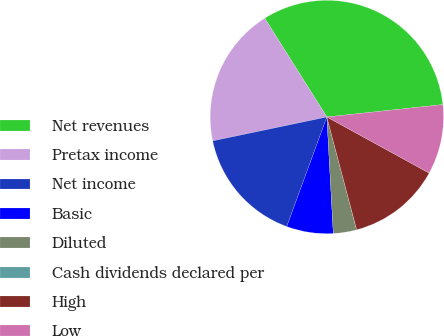<chart> <loc_0><loc_0><loc_500><loc_500><pie_chart><fcel>Net revenues<fcel>Pretax income<fcel>Net income<fcel>Basic<fcel>Diluted<fcel>Cash dividends declared per<fcel>High<fcel>Low<nl><fcel>32.24%<fcel>19.35%<fcel>16.13%<fcel>6.46%<fcel>3.23%<fcel>0.01%<fcel>12.9%<fcel>9.68%<nl></chart> 